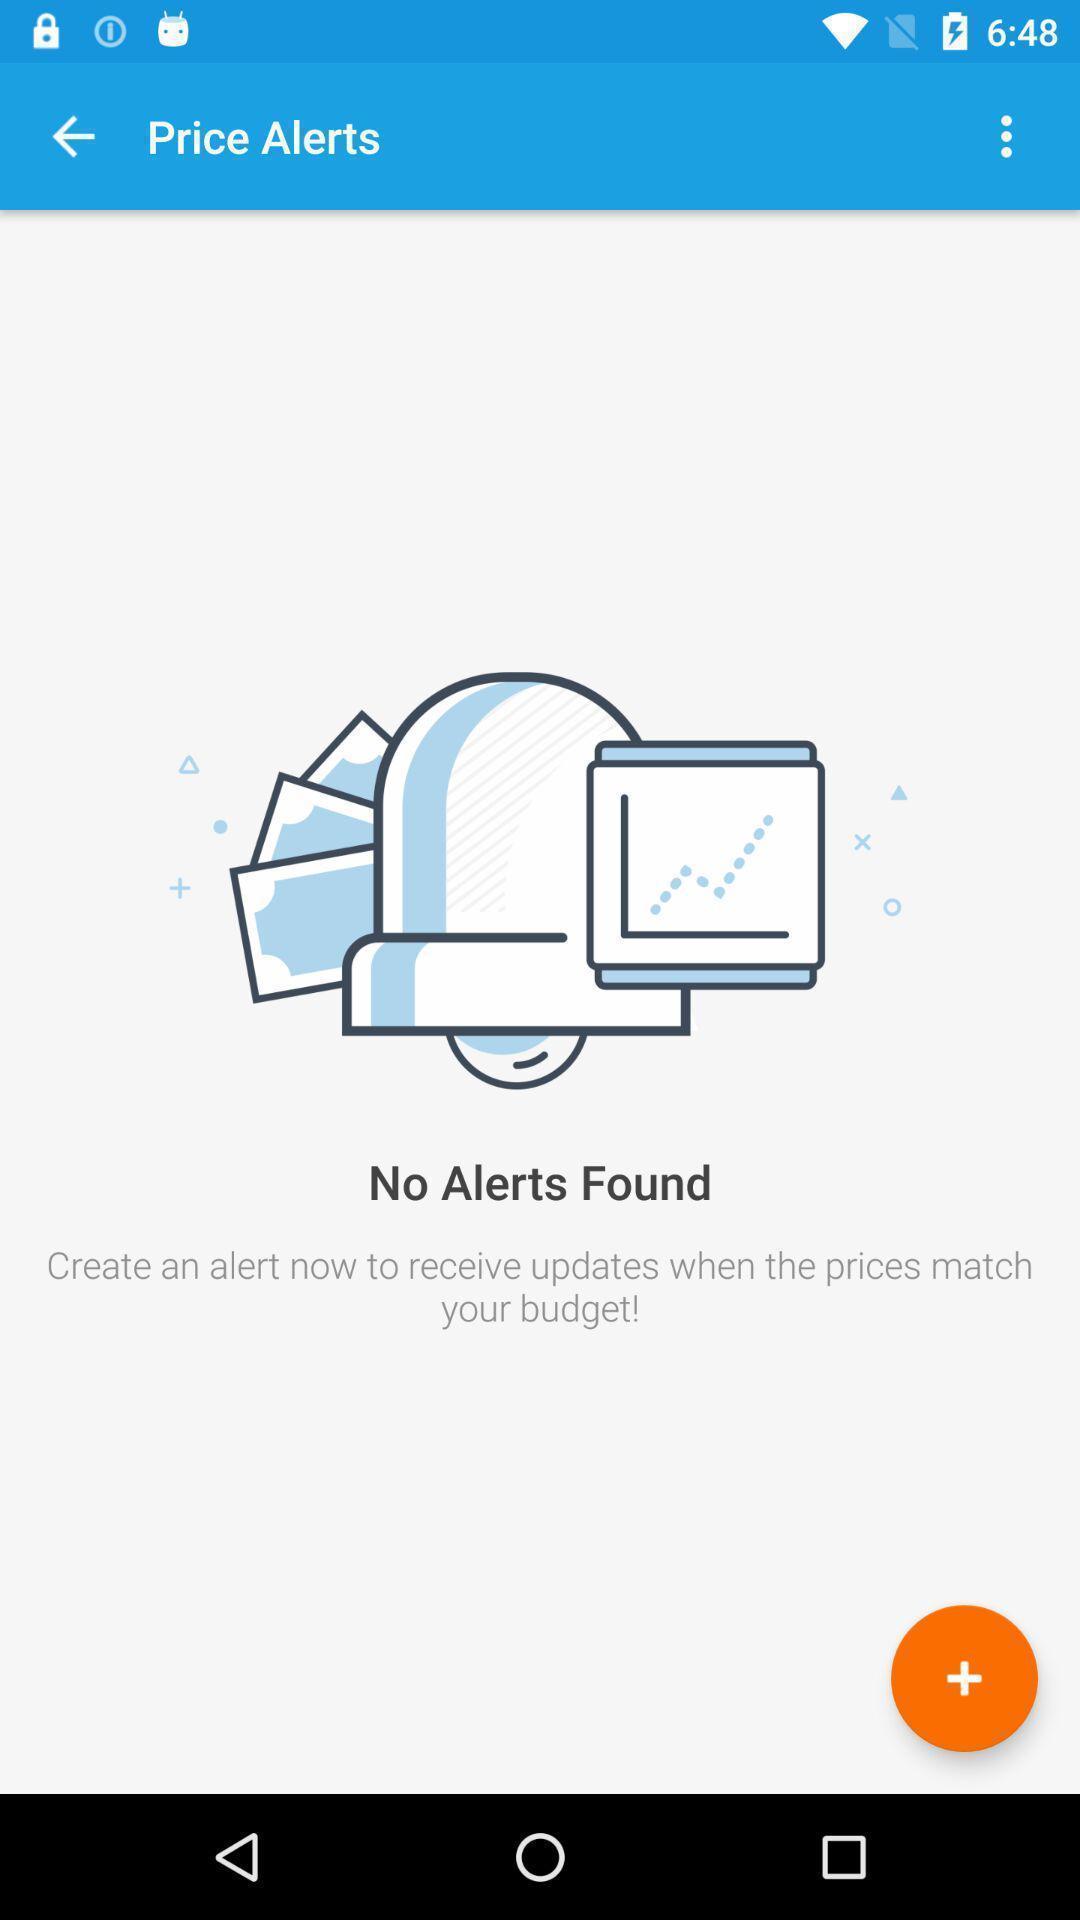Provide a description of this screenshot. Screen shows price alert page in travel application. 